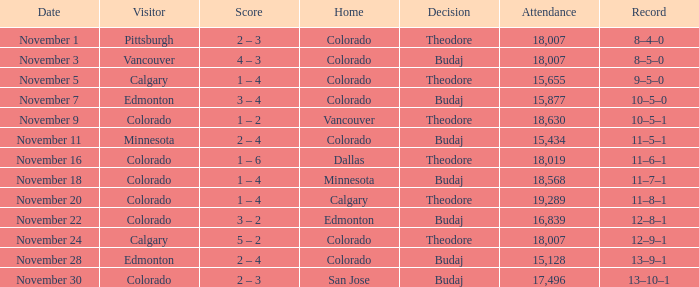Could you parse the entire table? {'header': ['Date', 'Visitor', 'Score', 'Home', 'Decision', 'Attendance', 'Record'], 'rows': [['November 1', 'Pittsburgh', '2 – 3', 'Colorado', 'Theodore', '18,007', '8–4–0'], ['November 3', 'Vancouver', '4 – 3', 'Colorado', 'Budaj', '18,007', '8–5–0'], ['November 5', 'Calgary', '1 – 4', 'Colorado', 'Theodore', '15,655', '9–5–0'], ['November 7', 'Edmonton', '3 – 4', 'Colorado', 'Budaj', '15,877', '10–5–0'], ['November 9', 'Colorado', '1 – 2', 'Vancouver', 'Theodore', '18,630', '10–5–1'], ['November 11', 'Minnesota', '2 – 4', 'Colorado', 'Budaj', '15,434', '11–5–1'], ['November 16', 'Colorado', '1 – 6', 'Dallas', 'Theodore', '18,019', '11–6–1'], ['November 18', 'Colorado', '1 – 4', 'Minnesota', 'Budaj', '18,568', '11–7–1'], ['November 20', 'Colorado', '1 – 4', 'Calgary', 'Theodore', '19,289', '11–8–1'], ['November 22', 'Colorado', '3 – 2', 'Edmonton', 'Budaj', '16,839', '12–8–1'], ['November 24', 'Calgary', '5 – 2', 'Colorado', 'Theodore', '18,007', '12–9–1'], ['November 28', 'Edmonton', '2 – 4', 'Colorado', 'Budaj', '15,128', '13–9–1'], ['November 30', 'Colorado', '2 – 3', 'San Jose', 'Budaj', '17,496', '13–10–1']]} Who played as the home team when calgary came with an audience of over 15,655? Colorado. 